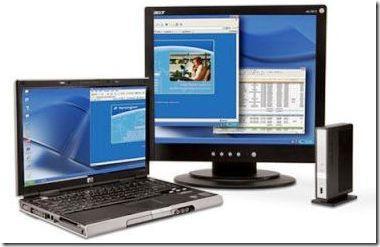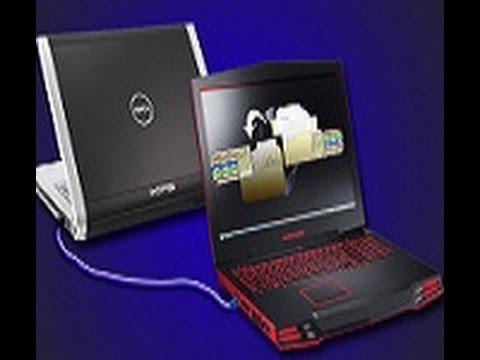The first image is the image on the left, the second image is the image on the right. Evaluate the accuracy of this statement regarding the images: "The top cover of one laptop is visible.". Is it true? Answer yes or no. Yes. The first image is the image on the left, the second image is the image on the right. Considering the images on both sides, is "Two laptops can be seen connected by a crossover cable." valid? Answer yes or no. Yes. 